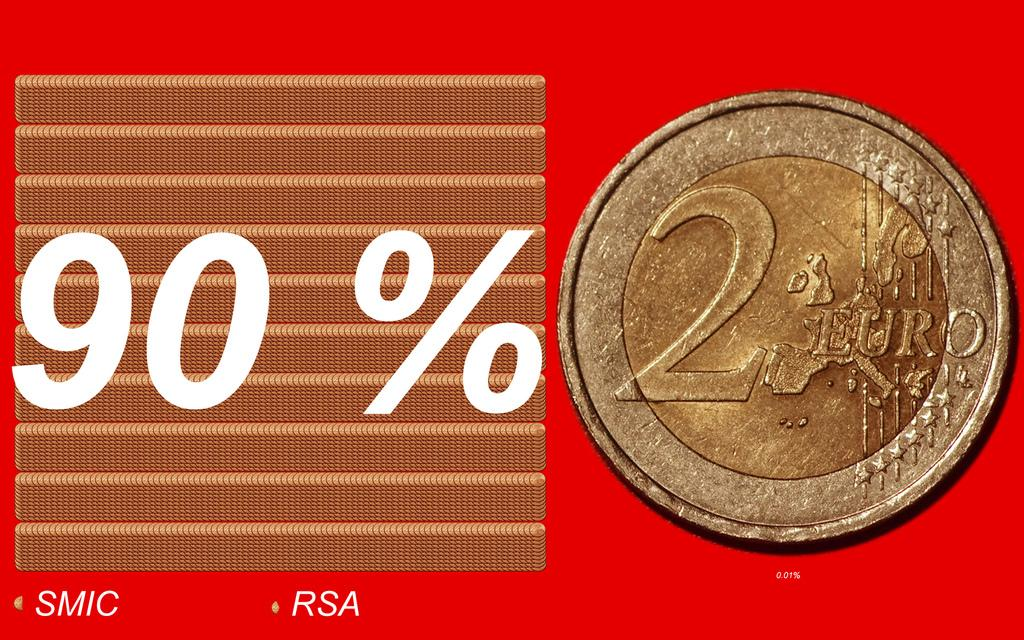<image>
Render a clear and concise summary of the photo. An ad for a coin that shows the number 2 on it and says 90% on the ad 